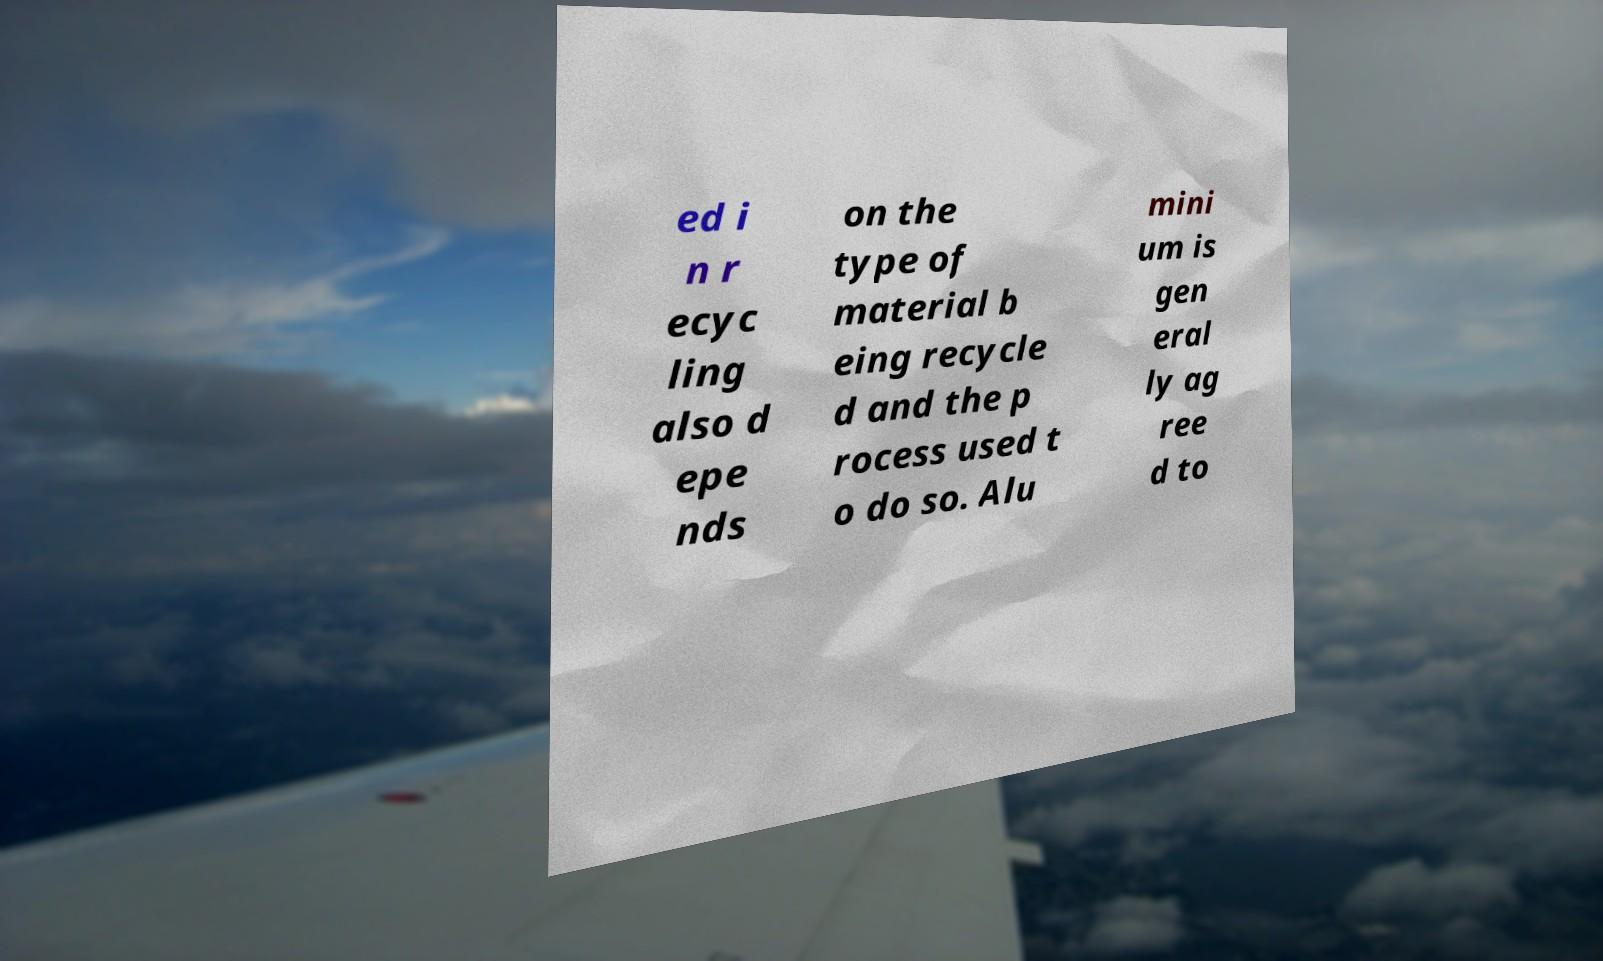I need the written content from this picture converted into text. Can you do that? ed i n r ecyc ling also d epe nds on the type of material b eing recycle d and the p rocess used t o do so. Alu mini um is gen eral ly ag ree d to 